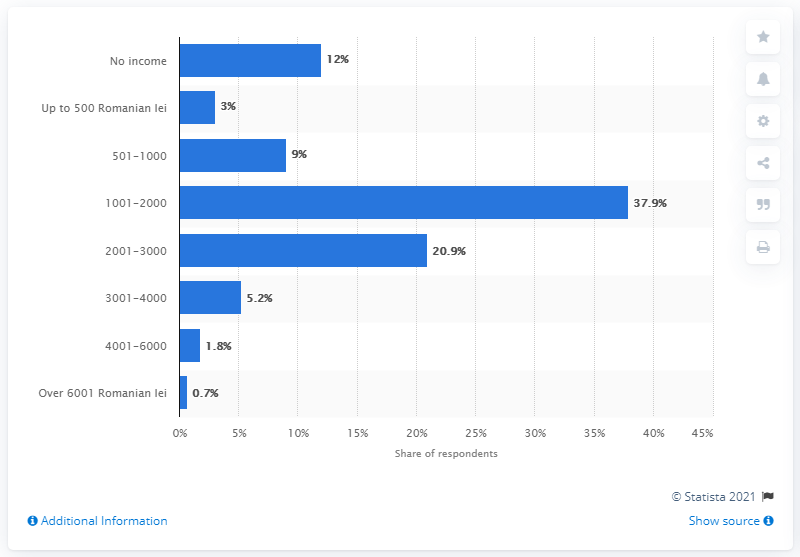List a handful of essential elements in this visual. According to the provided information, it is estimated that only 7% of Romanians earned more than 6,001 lei per month. 